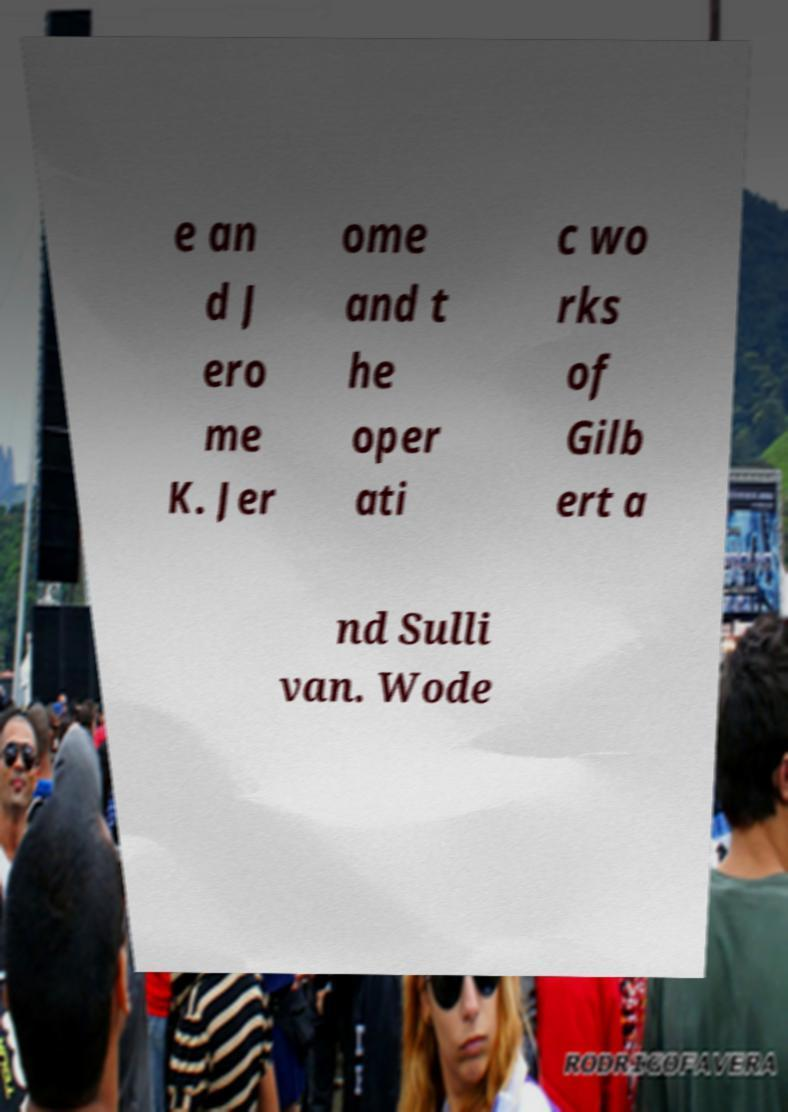There's text embedded in this image that I need extracted. Can you transcribe it verbatim? e an d J ero me K. Jer ome and t he oper ati c wo rks of Gilb ert a nd Sulli van. Wode 